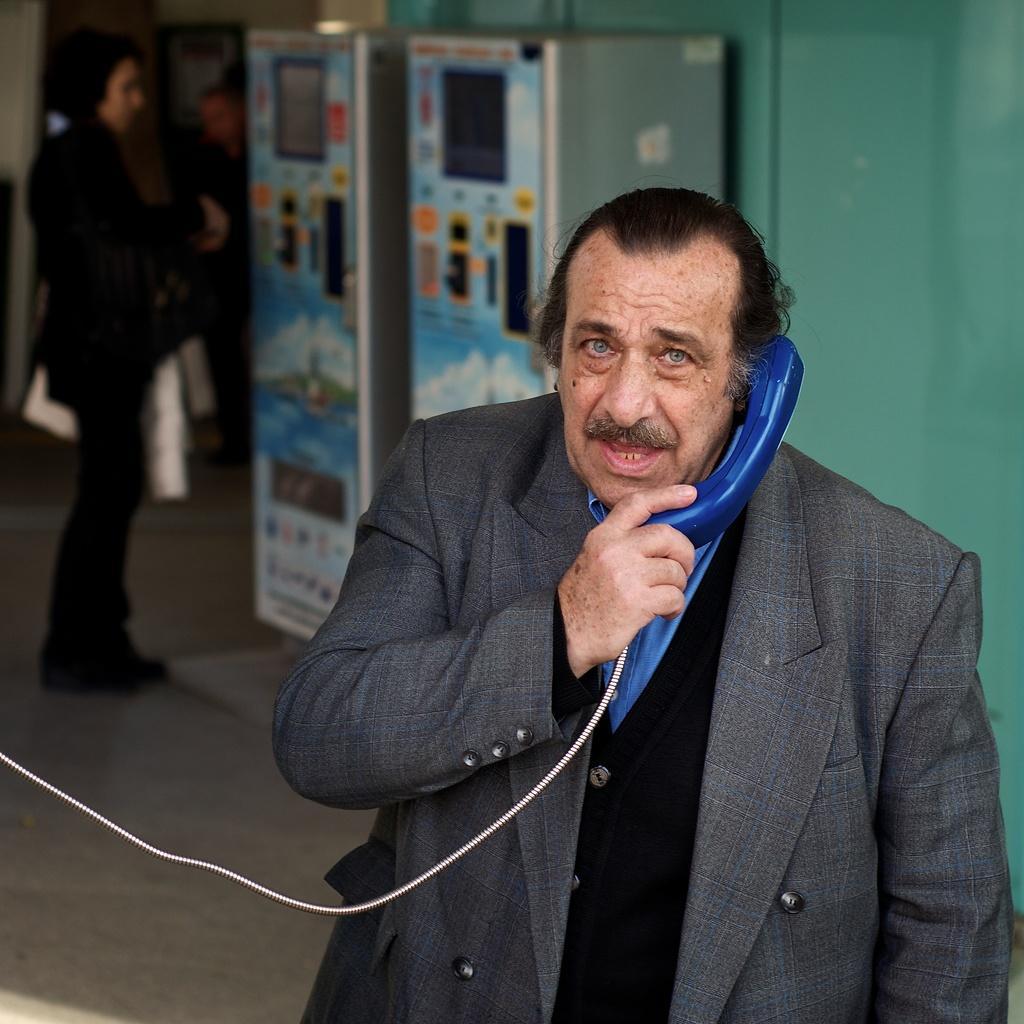Please provide a concise description of this image. In this image I can see some items in the shelf. On the left side I can see a kid. 